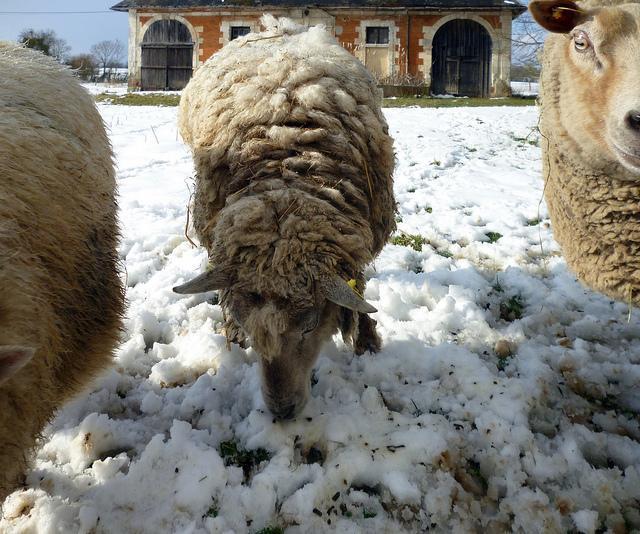How many eyes can be seen?
Give a very brief answer. 2. How many sheep are visible?
Give a very brief answer. 3. How many donuts are pictured?
Give a very brief answer. 0. 